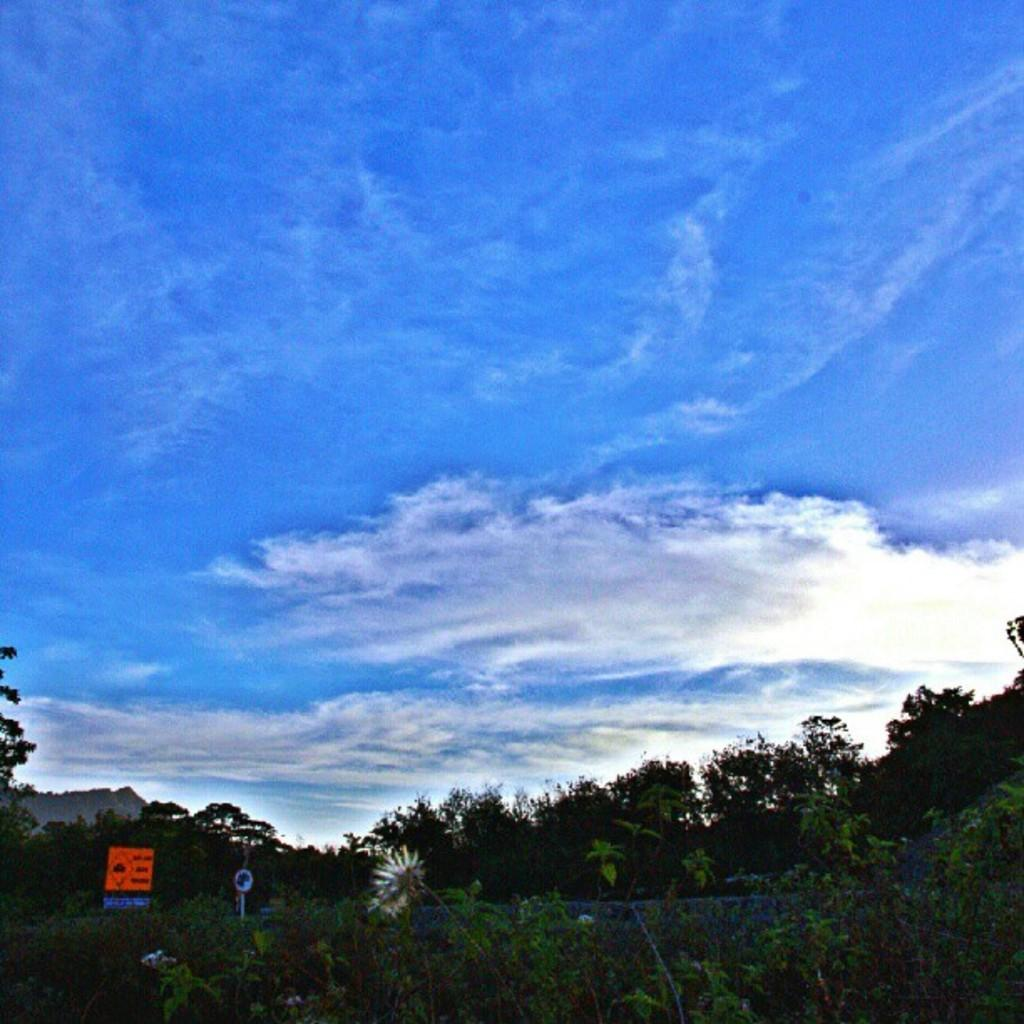What type of vegetation can be seen in the image? There are trees in the image. What part of the natural environment is visible in the image? The sky is visible in the background of the image. What type of wire is being used to hold the eggnog in the image? There is no wire or eggnog present in the image; it only features trees and the sky. 